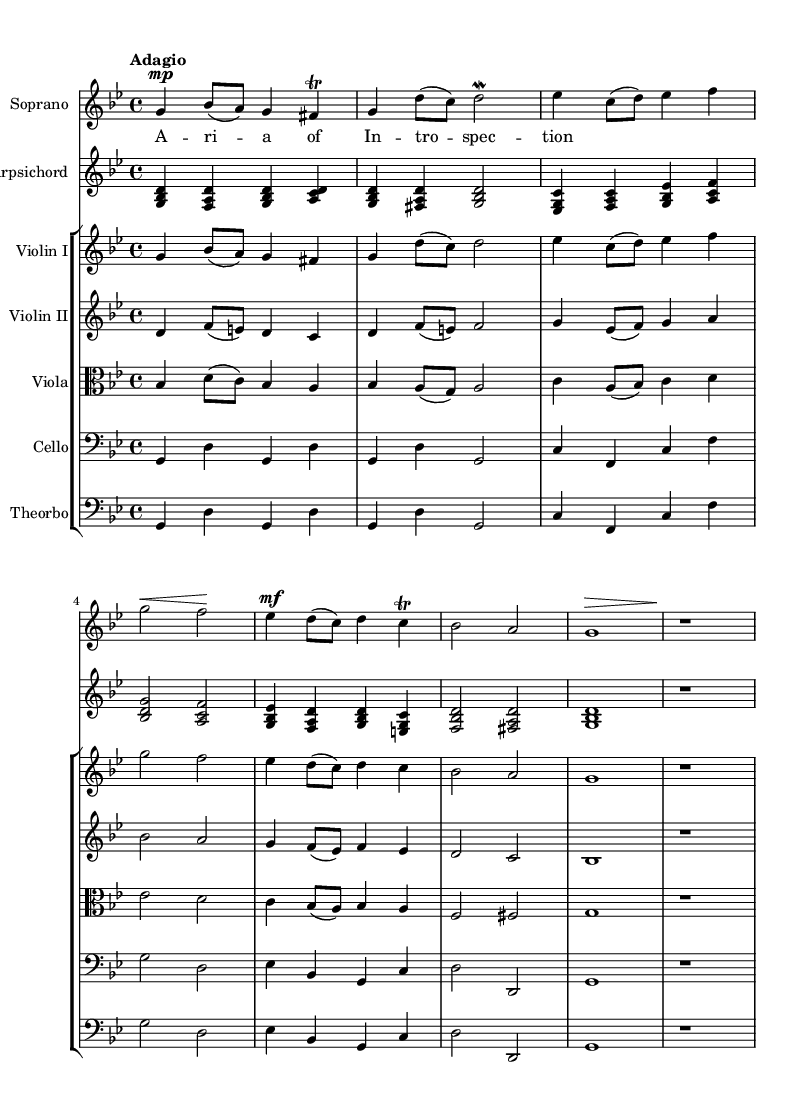What is the key signature of this music? The key signature is G minor, which has two flats (B flat and E flat) indicated at the beginning of the staff.
Answer: G minor What is the time signature of the piece? The time signature is 4/4, which is shown at the beginning of the score as a fraction with a 4 on top and a 4 on the bottom.
Answer: 4/4 What is the tempo marking for this piece? The tempo marking is "Adagio," meaning the music should be played at a slow tempo. This is indicated right after the time signature.
Answer: Adagio How many sections are there in the staff grouping? There are five sections in the staff grouping, represented by the presence of the different instruments (Violin I, Violin II, Viola, Cello, Theorbo).
Answer: Five What type of musical form is primarily used in this opera piece? This opera piece primarily uses an aria form, characterized by the solo vocal line with instrumental accompaniment, allowing for deep character expression. This can be inferred from the soprano part which includes lyrics.
Answer: Aria Which instrument has the highest pitch in this score? The soprano has the highest pitch in this score, indicated by the notation in the treble clef that is higher than the other instruments, especially the cello and theorbo.
Answer: Soprano What kind of ornament is used in the soprano line? The ornament used in the soprano line is a trill, indicated by the symbol "tr" placed above the note it should adorn, showing a rapid alternation between two notes.
Answer: Trill 